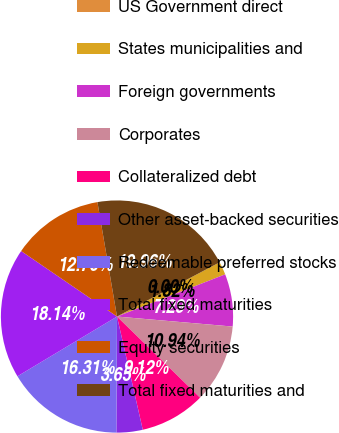<chart> <loc_0><loc_0><loc_500><loc_500><pie_chart><fcel>US Government direct<fcel>States municipalities and<fcel>Foreign governments<fcel>Corporates<fcel>Collateralized debt<fcel>Other asset-backed securities<fcel>Redeemable preferred stocks<fcel>Total fixed maturities<fcel>Equity securities<fcel>Total fixed maturities and<nl><fcel>0.0%<fcel>1.82%<fcel>7.29%<fcel>10.94%<fcel>9.12%<fcel>3.65%<fcel>16.31%<fcel>18.14%<fcel>12.76%<fcel>19.96%<nl></chart> 